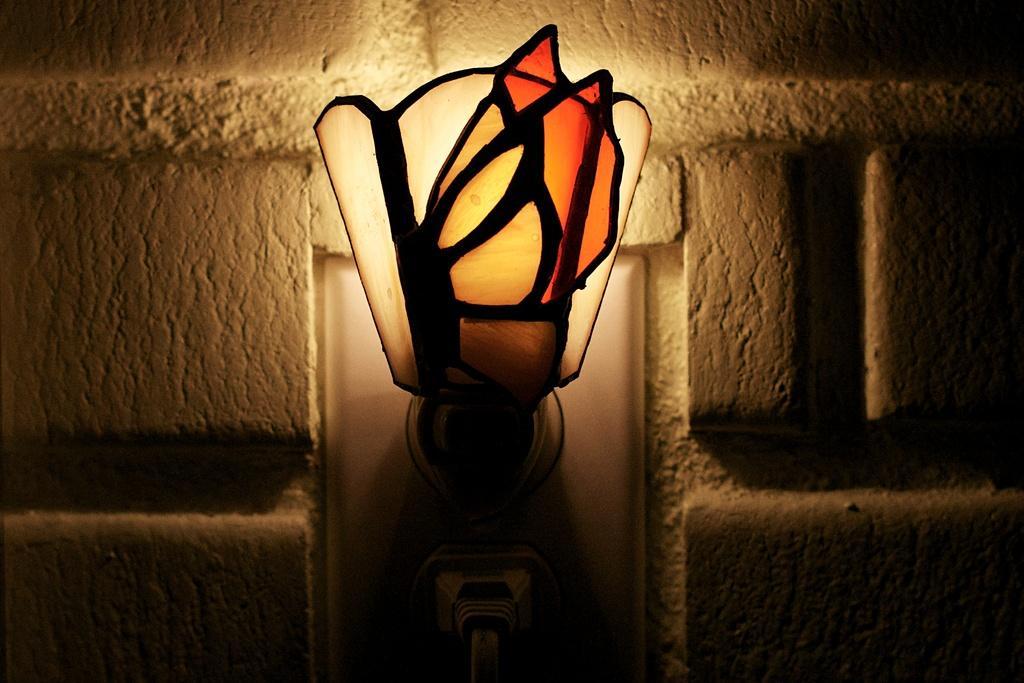Please provide a concise description of this image. In the image there is a lamp in the middle of wall. 